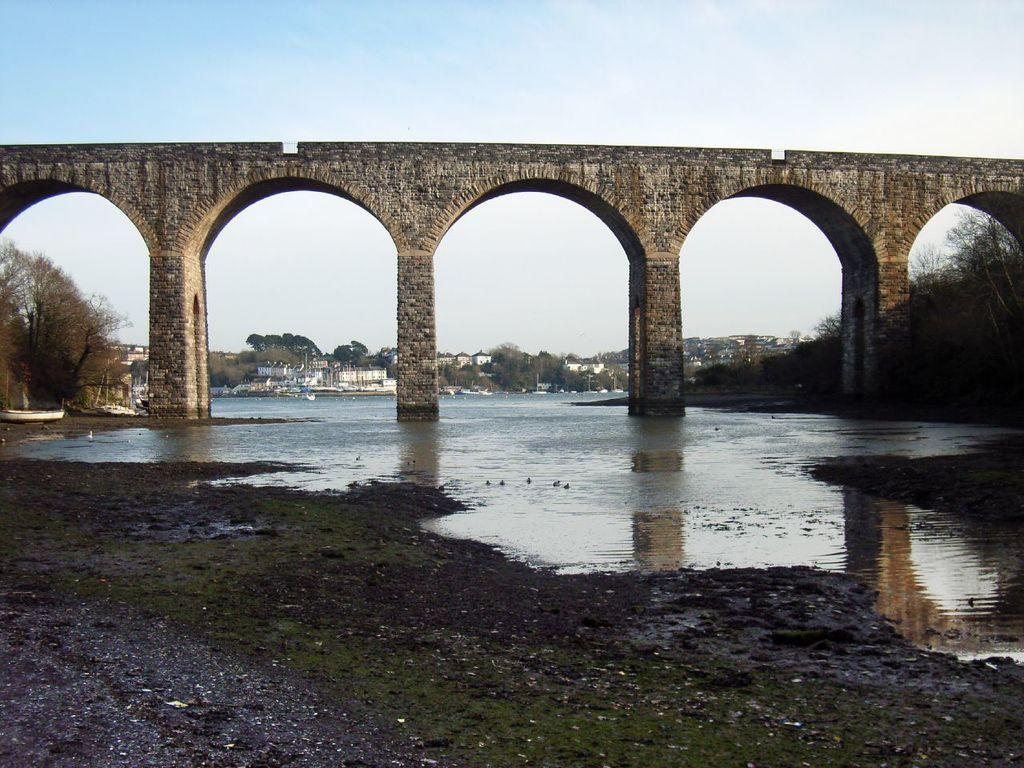What type of terrain is visible in the image? Ground and water are visible in the image. What structures can be seen in the background of the image? There is a bridge, buildings, and trees in the background of the image. What type of vehicles are present in the background of the image? There are boats in the background of the image. What part of the natural environment is visible in the image? The sky is visible in the background of the image. What other unspecified objects can be seen in the background of the image? There are some unspecified objects in the background of the image. What type of spring is visible in the image? There is no spring present in the image. What type of trade is taking place in the image? There is no trade taking place in the image. 